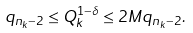Convert formula to latex. <formula><loc_0><loc_0><loc_500><loc_500>q _ { n _ { k } - 2 } \leq Q _ { k } ^ { 1 - \delta } \leq 2 M q _ { n _ { k } - 2 } .</formula> 